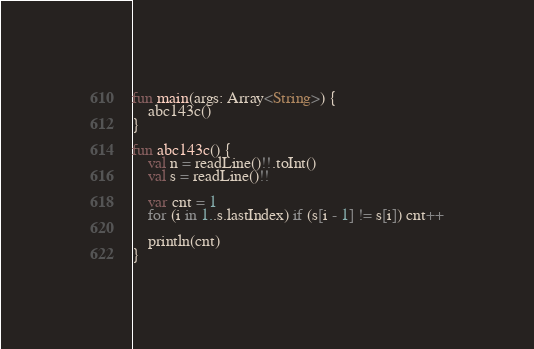Convert code to text. <code><loc_0><loc_0><loc_500><loc_500><_Kotlin_>fun main(args: Array<String>) {
    abc143c()
}

fun abc143c() {
    val n = readLine()!!.toInt()
    val s = readLine()!!

    var cnt = 1
    for (i in 1..s.lastIndex) if (s[i - 1] != s[i]) cnt++

    println(cnt)
}
</code> 